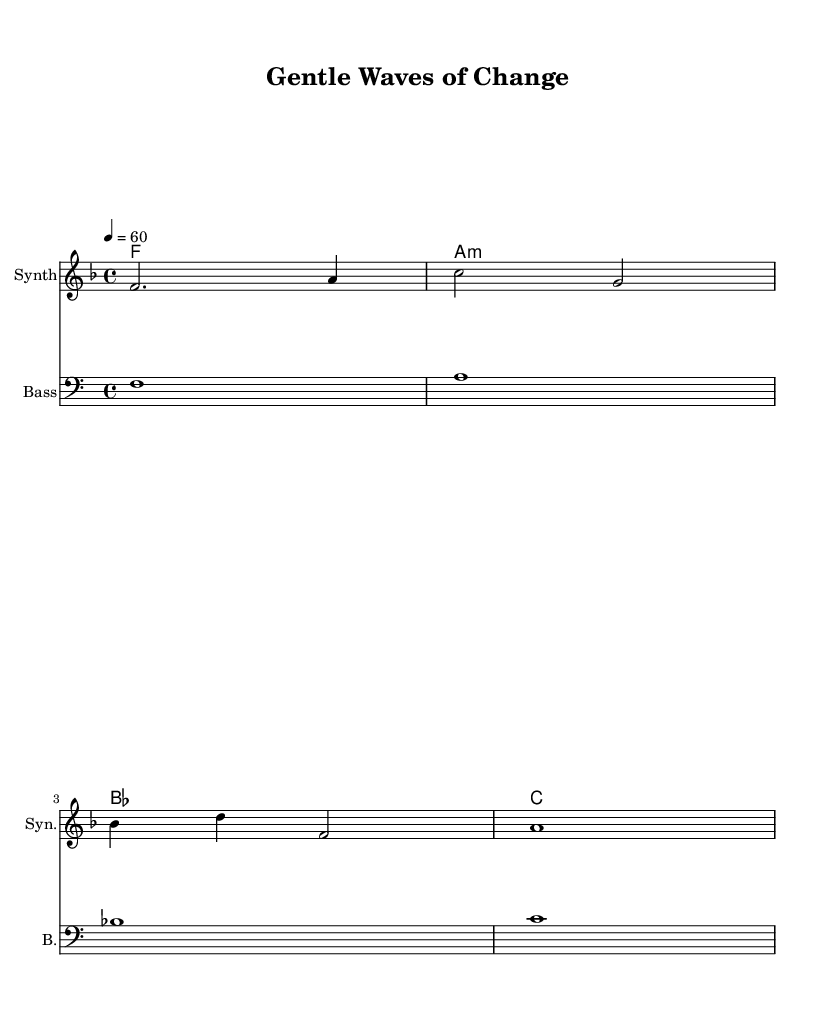What is the key signature of this music? The key signature is F major, which has one flat (B flat). This can be identified at the beginning of the score, where the key signature is indicated.
Answer: F major What is the time signature of this music? The time signature is 4/4, noted at the beginning of the score right after the key signature, indicating four beats per measure.
Answer: 4/4 What is the tempo marking for this piece? The tempo marking is 60 beats per minute, which is specified as "4 = 60" in the global section, indicating the beat for a quarter note.
Answer: 60 How many measures are in the melody? The melody consists of four measures, as seen by counting the vertical bar lines that separate the measures in the staff.
Answer: 4 What type of instrument is notated for the melody? The instrument for the melody is indicated as "Synth," which is specified in the instrument name section of the score. This suggests a synthetic sound typical in electronic music.
Answer: Synth What is the first note of the melody? The first note of the melody is F, which is the first note written in the melody part of the staff, located in the second octave of the piano.
Answer: F What kind of chords are used in the harmonies section? The chords used in the harmonies section are F major, A minor, B flat major, and C major chords, indicated by the chord names written above the staff.
Answer: F, A minor, B flat, C major 